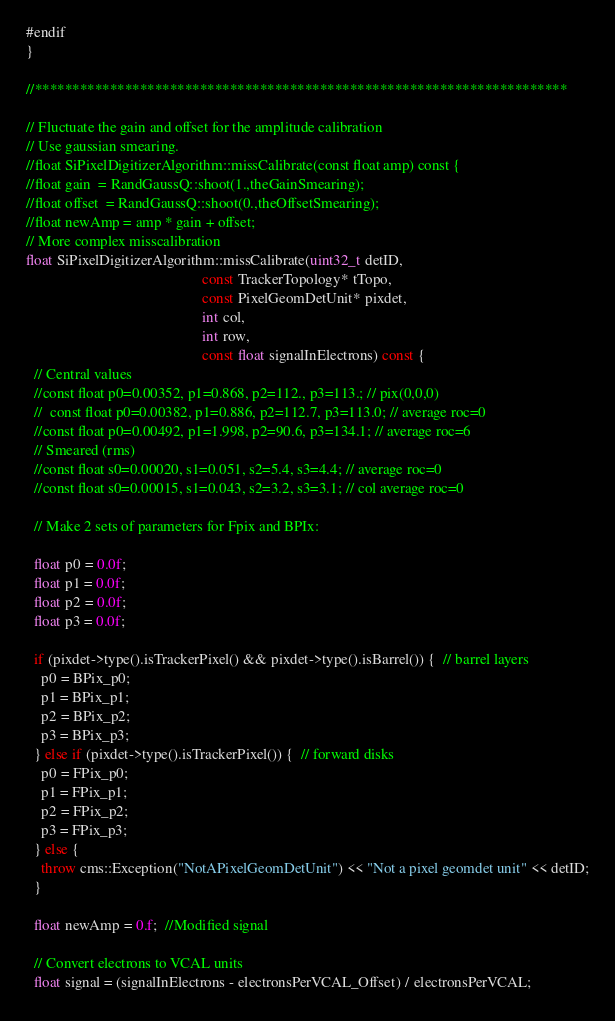Convert code to text. <code><loc_0><loc_0><loc_500><loc_500><_C++_>#endif
}

//***********************************************************************

// Fluctuate the gain and offset for the amplitude calibration
// Use gaussian smearing.
//float SiPixelDigitizerAlgorithm::missCalibrate(const float amp) const {
//float gain  = RandGaussQ::shoot(1.,theGainSmearing);
//float offset  = RandGaussQ::shoot(0.,theOffsetSmearing);
//float newAmp = amp * gain + offset;
// More complex misscalibration
float SiPixelDigitizerAlgorithm::missCalibrate(uint32_t detID,
                                               const TrackerTopology* tTopo,
                                               const PixelGeomDetUnit* pixdet,
                                               int col,
                                               int row,
                                               const float signalInElectrons) const {
  // Central values
  //const float p0=0.00352, p1=0.868, p2=112., p3=113.; // pix(0,0,0)
  //  const float p0=0.00382, p1=0.886, p2=112.7, p3=113.0; // average roc=0
  //const float p0=0.00492, p1=1.998, p2=90.6, p3=134.1; // average roc=6
  // Smeared (rms)
  //const float s0=0.00020, s1=0.051, s2=5.4, s3=4.4; // average roc=0
  //const float s0=0.00015, s1=0.043, s2=3.2, s3=3.1; // col average roc=0

  // Make 2 sets of parameters for Fpix and BPIx:

  float p0 = 0.0f;
  float p1 = 0.0f;
  float p2 = 0.0f;
  float p3 = 0.0f;

  if (pixdet->type().isTrackerPixel() && pixdet->type().isBarrel()) {  // barrel layers
    p0 = BPix_p0;
    p1 = BPix_p1;
    p2 = BPix_p2;
    p3 = BPix_p3;
  } else if (pixdet->type().isTrackerPixel()) {  // forward disks
    p0 = FPix_p0;
    p1 = FPix_p1;
    p2 = FPix_p2;
    p3 = FPix_p3;
  } else {
    throw cms::Exception("NotAPixelGeomDetUnit") << "Not a pixel geomdet unit" << detID;
  }

  float newAmp = 0.f;  //Modified signal

  // Convert electrons to VCAL units
  float signal = (signalInElectrons - electronsPerVCAL_Offset) / electronsPerVCAL;
</code> 